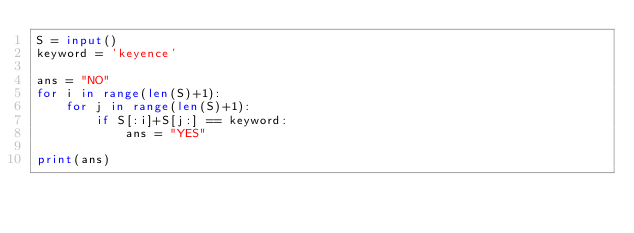<code> <loc_0><loc_0><loc_500><loc_500><_Python_>S = input()
keyword = 'keyence'

ans = "NO"
for i in range(len(S)+1):
    for j in range(len(S)+1):
        if S[:i]+S[j:] == keyword:
            ans = "YES"
            
print(ans)</code> 